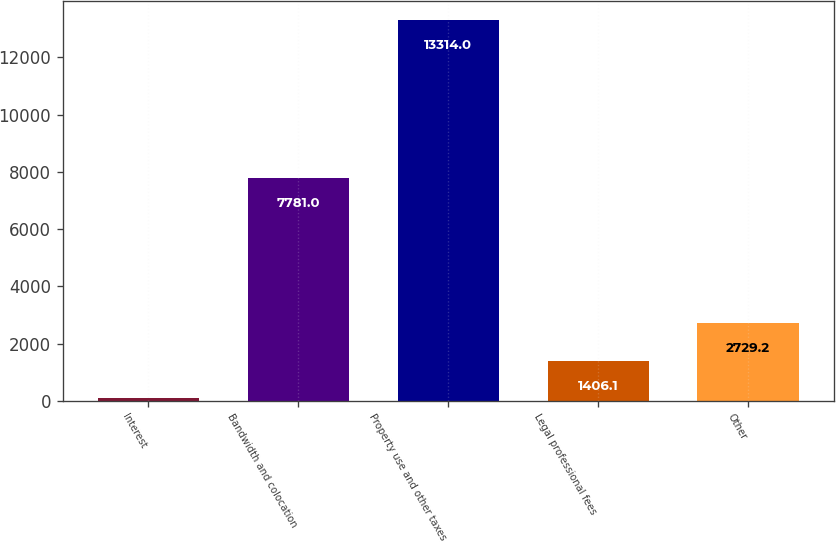Convert chart to OTSL. <chart><loc_0><loc_0><loc_500><loc_500><bar_chart><fcel>Interest<fcel>Bandwidth and colocation<fcel>Property use and other taxes<fcel>Legal professional fees<fcel>Other<nl><fcel>83<fcel>7781<fcel>13314<fcel>1406.1<fcel>2729.2<nl></chart> 